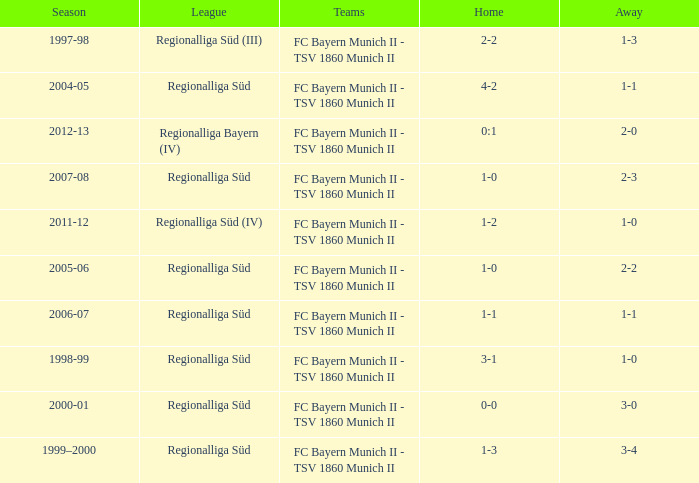Which teams were in the 2006-07 season? FC Bayern Munich II - TSV 1860 Munich II. 